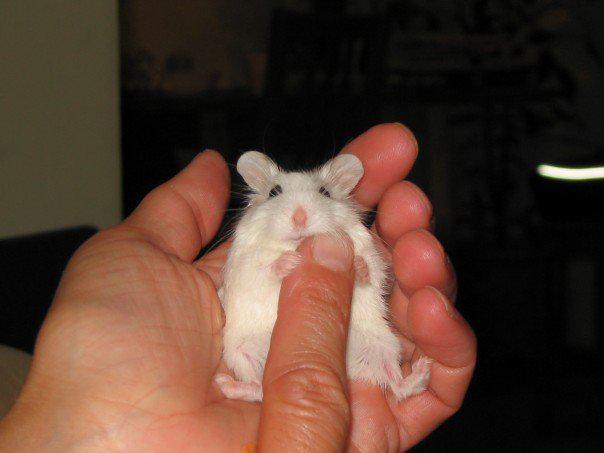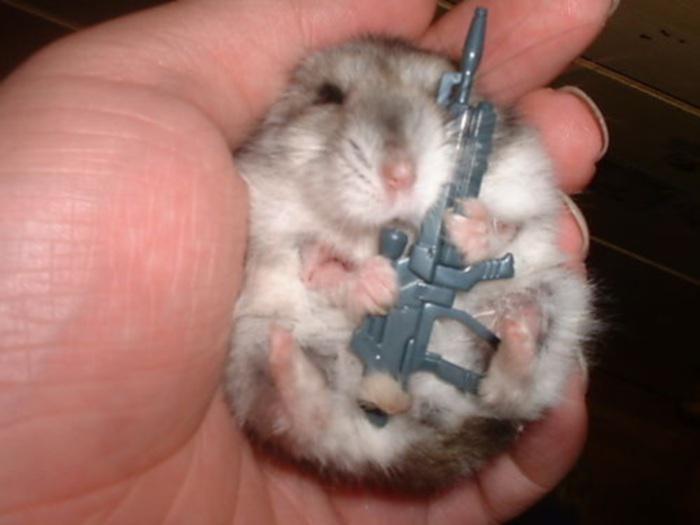The first image is the image on the left, the second image is the image on the right. Analyze the images presented: Is the assertion "The right image contains a human touching a rodent." valid? Answer yes or no. Yes. The first image is the image on the left, the second image is the image on the right. Given the left and right images, does the statement "Each image contains a single pet rodent, and one of the rodents is held in a pair of upturned hands." hold true? Answer yes or no. No. 